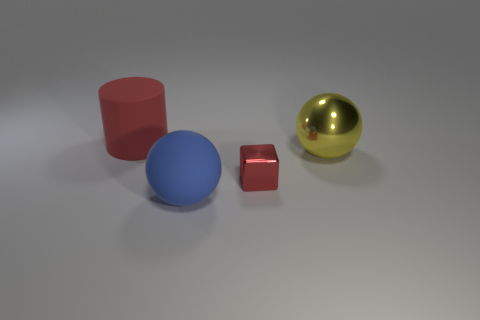Is there a brown block that has the same size as the yellow metallic thing?
Keep it short and to the point. No. What color is the cube?
Your response must be concise. Red. Is the red shiny block the same size as the red matte cylinder?
Your answer should be very brief. No. How many objects are either big blue balls or large metallic spheres?
Your answer should be compact. 2. Is the number of tiny cubes on the left side of the tiny cube the same as the number of big red matte cylinders?
Offer a terse response. No. Is there a red matte cylinder right of the yellow object to the right of the big thing left of the blue rubber sphere?
Your answer should be very brief. No. What is the color of the other object that is the same material as the yellow object?
Ensure brevity in your answer.  Red. There is a ball behind the metallic block; is its color the same as the large matte ball?
Your answer should be very brief. No. How many cylinders are either small blue shiny objects or rubber things?
Ensure brevity in your answer.  1. There is a red thing in front of the red object that is behind the big object on the right side of the blue ball; what is its size?
Provide a succinct answer. Small. 